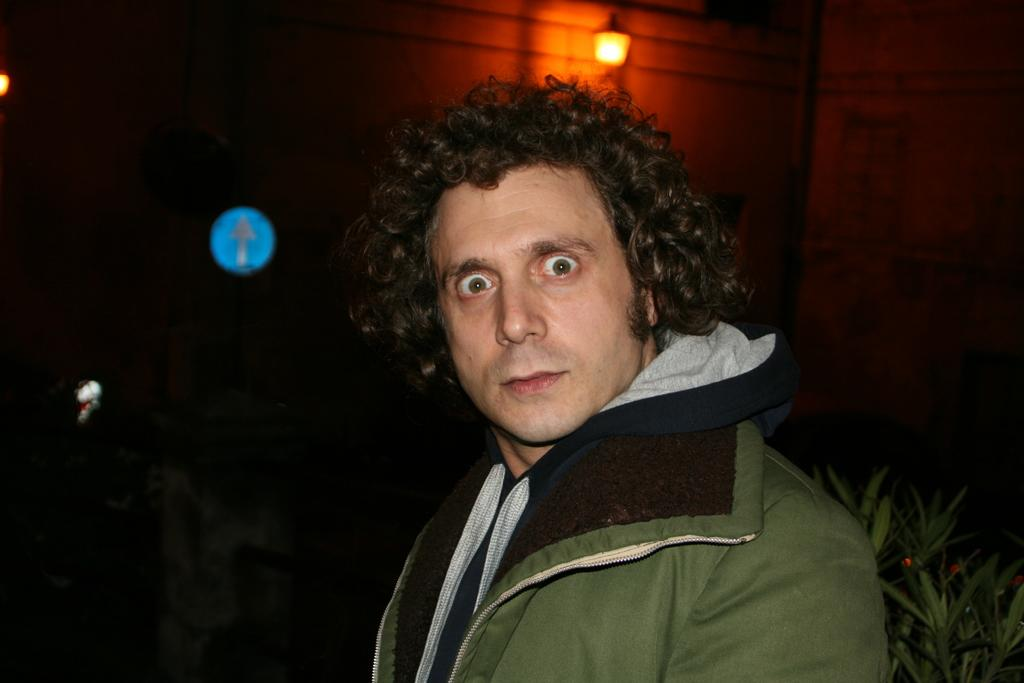What is present in the image along with the person? There is a plant in the image. Can you describe the lighting conditions in the image? There is light visible in the background of the image. What type of cap is the person wearing in the image? There is no cap visible in the image; the person is not wearing one. Is there any sleet present in the image? There is no mention of sleet in the provided facts, and it is not visible in the image. 